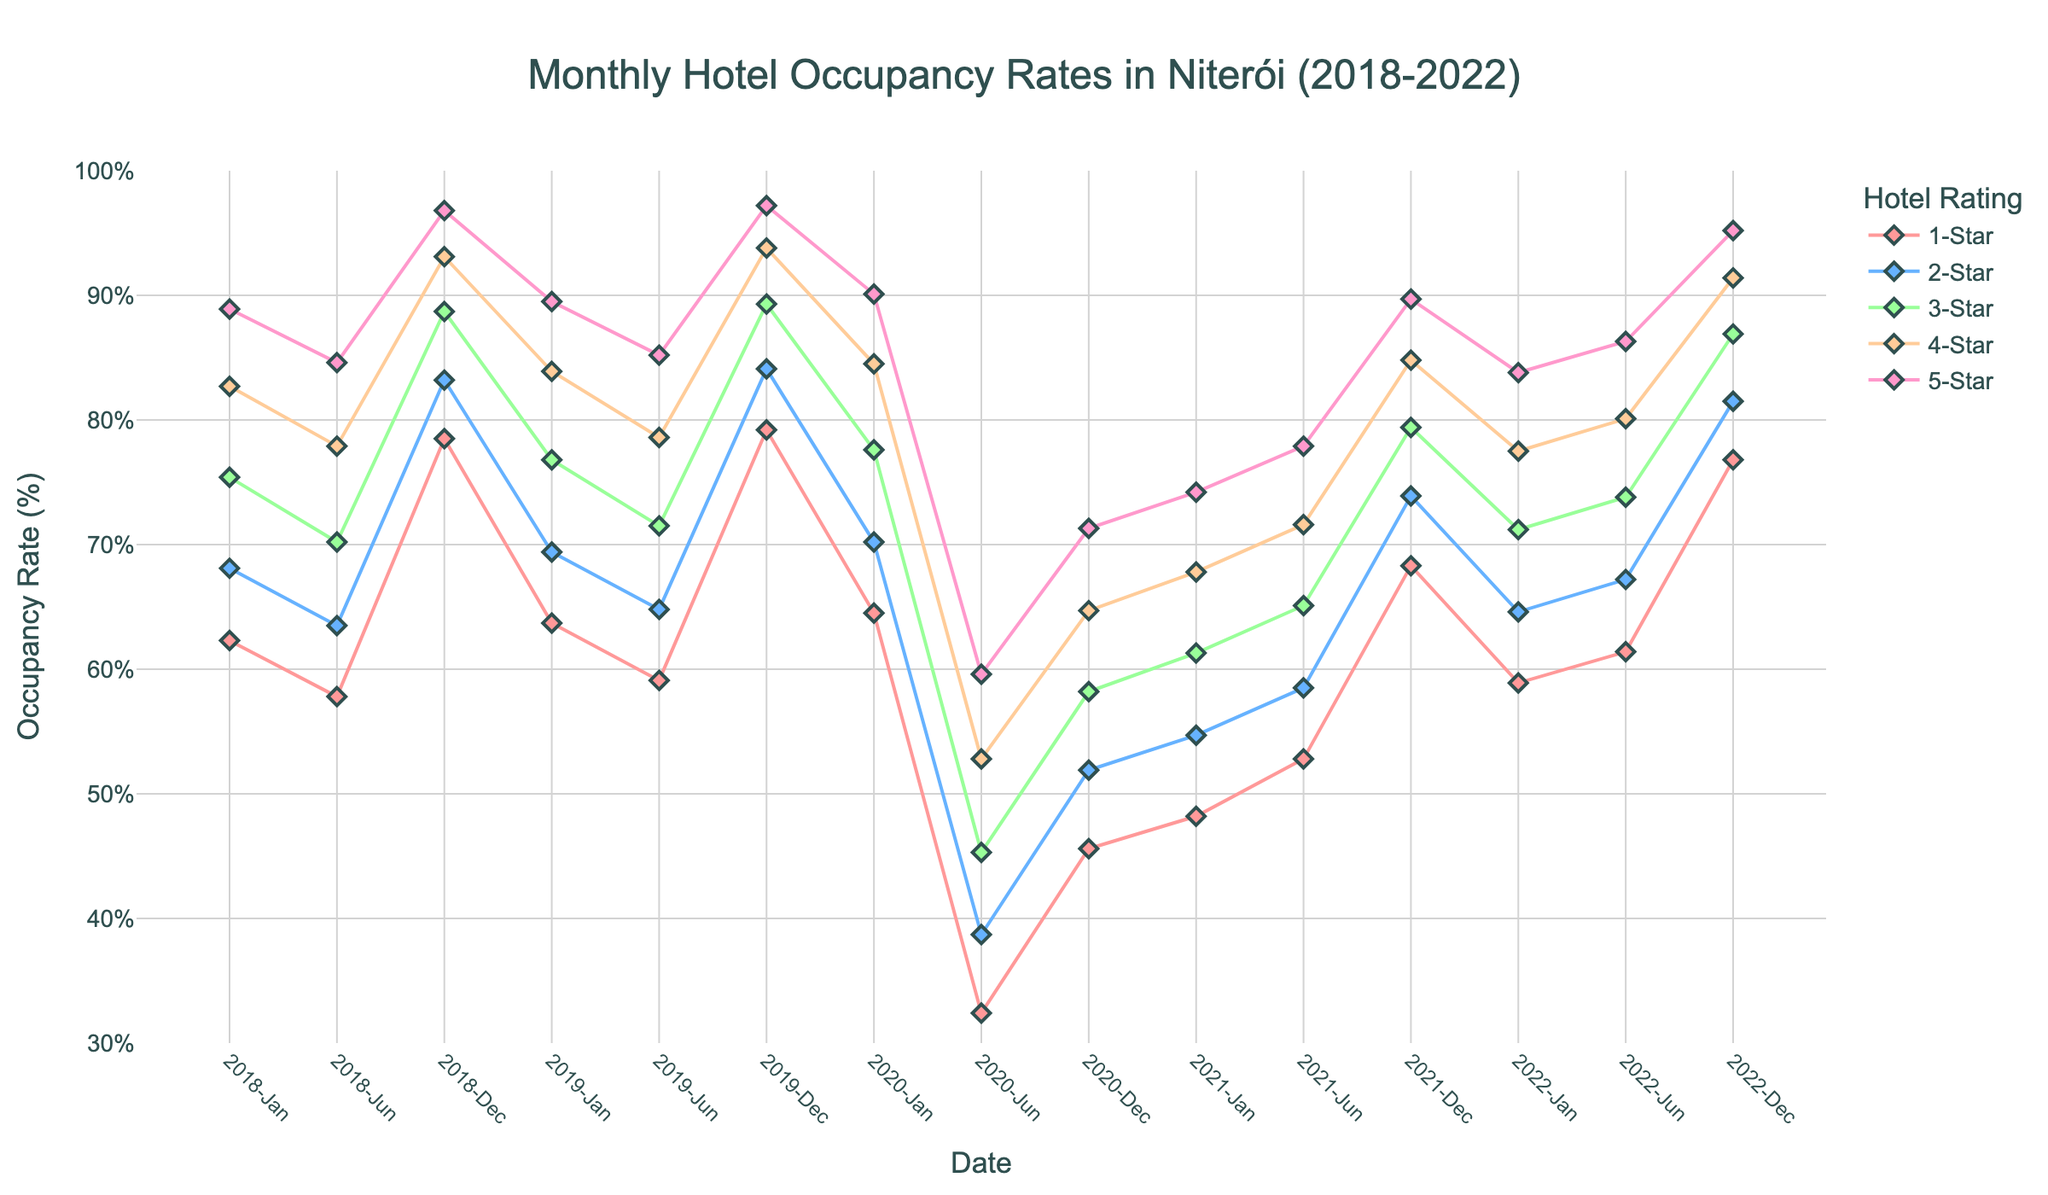What was the lowest occupancy rate for all ratings in 2020? The lowest occupancy rate can be found by identifying the minimum value for each star rating in 2020 and then comparing them. From the plot for 2020, we see that the lowest values are 32.4% (1-Star), 38.7% (2-Star), 45.3% (3-Star), 52.8% (4-Star), and 59.6% (5-Star). The lowest among these is 32.4%.
Answer: 32.4% In which month and year did the 5-star hotels have the highest occupancy rate? By examining the plot for the 5-Star line (pink), we can see the peak points. The highest value appears in December 2019 with an occupancy rate of 97.2%.
Answer: December 2019 Which hotel rating saw the biggest drop in occupancy rate between January 2020 and June 2020? To determine the biggest drop, find the difference between January 2020 and June 2020 for each rating: 1-Star (64.5% - 32.4% = 32.1%), 2-Star (70.2% - 38.7% = 31.5%), 3-Star (77.6% - 45.3% = 32.3%), 4-Star (84.5% - 52.8% = 31.7%), 5-Star (90.1% - 59.6% = 30.5%). The 1-Star rating experienced the largest drop of 32.1%.
Answer: 1-Star How does the average occupancy rate of 3-star hotels in Decembers compare to Junes over these years? Calculate the average for Decembers and Junes. Decembers: (88.7 + 89.3 + 58.2 + 79.4 + 86.9) / 5 = 80.5%. Junes: (70.2 + 71.5 + 45.3 + 65.1 + 73.8) / 5 = 65.18%.
Answer: Decembers have a higher average During which year did 3-star hotels have the lowest December occupancy rate? Identify December occupancy rates for 3-star hotels over the years: Dec 2018 (88.7%), Dec 2019 (89.3%), Dec 2020 (58.2%), Dec 2021 (79.4%), Dec 2022 (86.9%). The lowest is December 2020 at 58.2%.
Answer: 2020 What can you infer about the general trend for hotel occupancy rates during the COVID-19 pandemic in 2020? Observing trends across all ratings, there is a noticeable drop in occupancy rates in June 2020 compared to January 2020. Most ratings show a decline, indicating the impact of the pandemic on hotel occupancy.
Answer: Significant drop in 2020 Did 4-star hotels ever exceed 90% occupancy in the given period? Check the plot for 4-star hotels' highest points: Dec 2018 (93.1%), Dec 2019 (93.8%), Dec 2022 (91.4%). All exceed 90%, confirming that the 90% mark was exceeded at least in these months.
Answer: Yes How does the occupancy rate in Jun 2022 for 2-star hotels compare to Jun 2021 for the same rating? From the plot, Jun 2022 (67.2%) and Jun 2021 (58.5%). Compare these values directly.
Answer: Jun 2022 is higher What is the trend for 5-star hotel occupancy rates across December months? Look for December values across years for 5-Star hotels and observe if they increase, decrease, or fluctuate: Dec 2018 (96.8%), Dec 2019 (97.2%), Dec 2020 (71.3%), Dec 2021 (89.7%), Dec 2022 (95.2%). Notice an upward trend post-2020.
Answer: Increasing trend post-2020 Which hotel rating showed the most resilience during the pandemic, maintaining higher occupancy rates in 2020? By examining the lowest dips in June 2020, we note that 5-Star hotels maintained the highest occupancy rate (59.6%) during this period.
Answer: 5-Star 